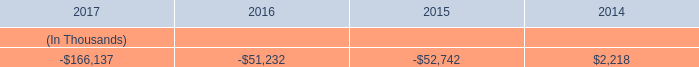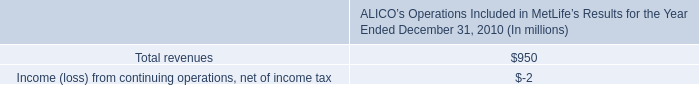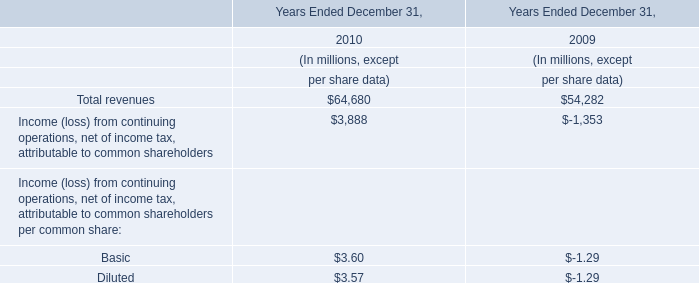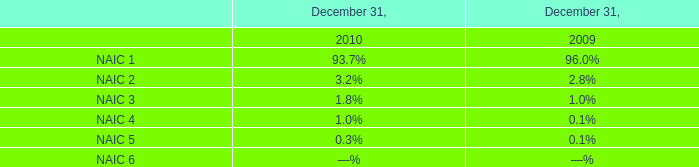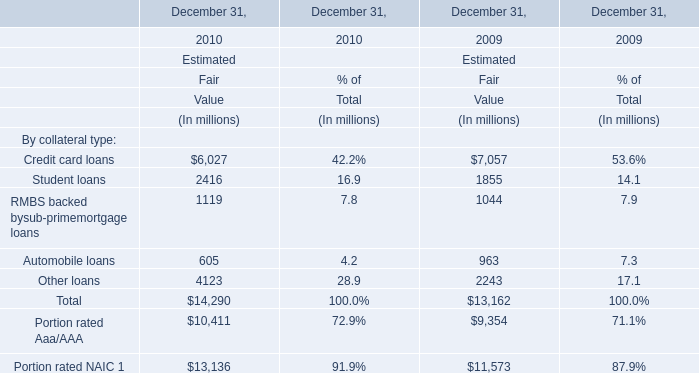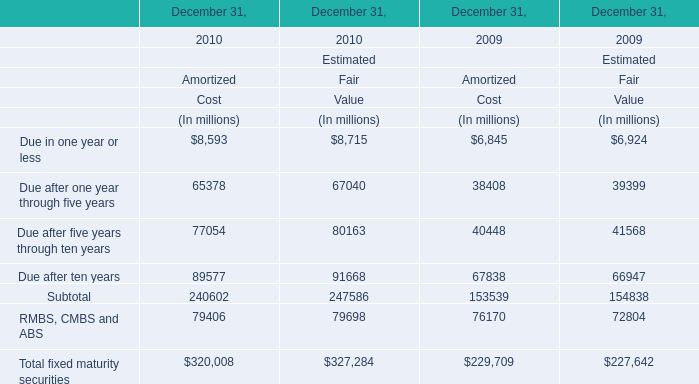Which element has the second largest number in 2010 ? 
Answer: Portion rated NAIC. 